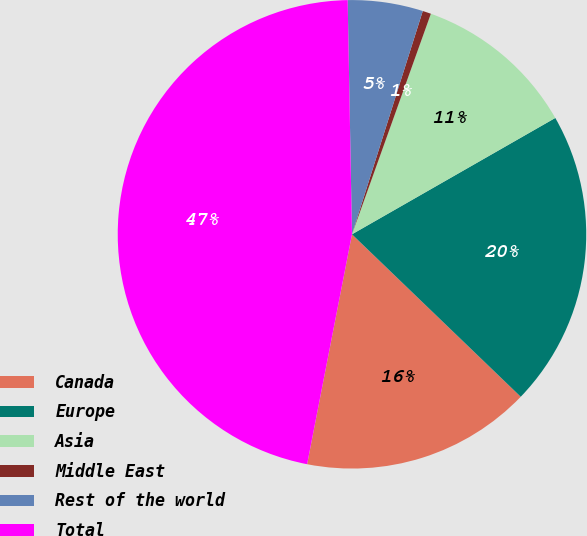Convert chart to OTSL. <chart><loc_0><loc_0><loc_500><loc_500><pie_chart><fcel>Canada<fcel>Europe<fcel>Asia<fcel>Middle East<fcel>Rest of the world<fcel>Total<nl><fcel>15.87%<fcel>20.47%<fcel>11.26%<fcel>0.58%<fcel>5.18%<fcel>46.64%<nl></chart> 